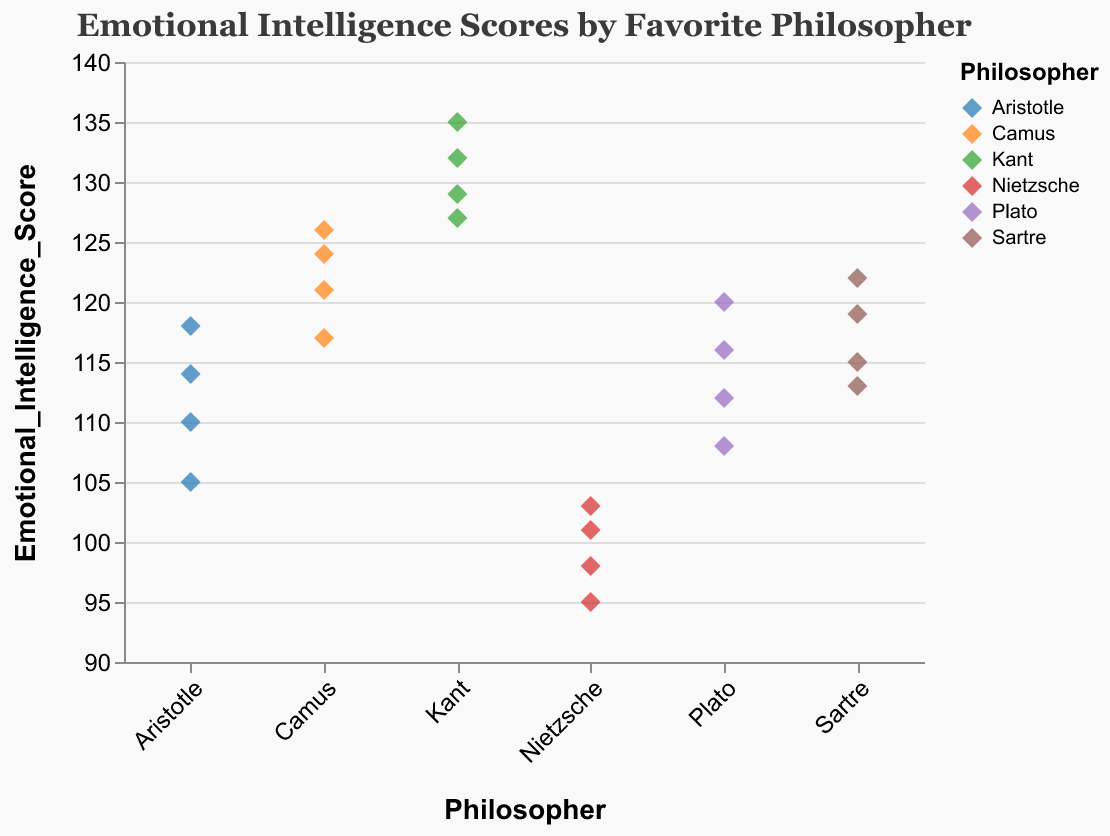What is the title of the figure? The title is written at the top of the figure and it states what the plot is about. The title reads "Emotional Intelligence Scores by Favorite Philosopher".
Answer: Emotional Intelligence Scores by Favorite Philosopher How many philosophers are represented in the figure? The figure shows points categorized by philosopher names along the x-axis. Counting these unique names, we see there are 6 philosophers represented.
Answer: 6 What is the emotional intelligence score range for Kant followers? Finding the lowest and highest points for the "Kant" group on the y-axis, we see the scores range between 127 and 135.
Answer: 127 to 135 Which philosopher’s followers have the highest emotional intelligence score, and what is that score? Looking for the highest point on the y-axis, we find it corresponds to a Kant follower with a score of 135.
Answer: Kant, 135 How do the median emotional intelligence scores of Aristotle and Nietzsche compare? Find the middle score for each philosopher group. For Aristotle, the scores are 105, 110, 114, and 118. The median is (110+114)/2 = 112. For Nietzsche, the scores are 95, 98, 101, and 103. The median is (98+101)/2 = 99.5.
Answer: Aristotle's median is higher than Nietzsche's What is the total number of data points (students) in the figure? Counting all dots in the figure, we get a total. Each point represents one student's score, and there are 24 such points.
Answer: 24 Who has the lowest emotional intelligence score, and what is the score? The lowest point on the y-axis for all philosophers is under Nietzsche, which is 95.
Answer: Nietzsche, 95 Which philosopher’s followers show the widest range of emotional intelligence scores? Calculate the range (max score - min score) for each philosopher. Kant: 135-127=8, Plato: 120-108=12, Aristotle: 118-105=13, Nietzsche: 103-95=8, Sartre: 122-113=9, Camus: 126-117=9. Aristotle has the widest range (13).
Answer: Aristotle Which philosopher's followers have an emotional intelligence score around 120? Look for points clustered around 120 on the y-axis. Plato (120), Camus (117, 121, 124, 126) and Sartre (119, 122).
Answer: Plato, Camus, Sartre What's the average emotional intelligence score for followers of Sartre? Sum Sartre's scores (115, 119, 113, 122) and divide by the number of scores. Total is 115+119+113+122 = 469. Average is 469/4 = 117.25.
Answer: 117.25 